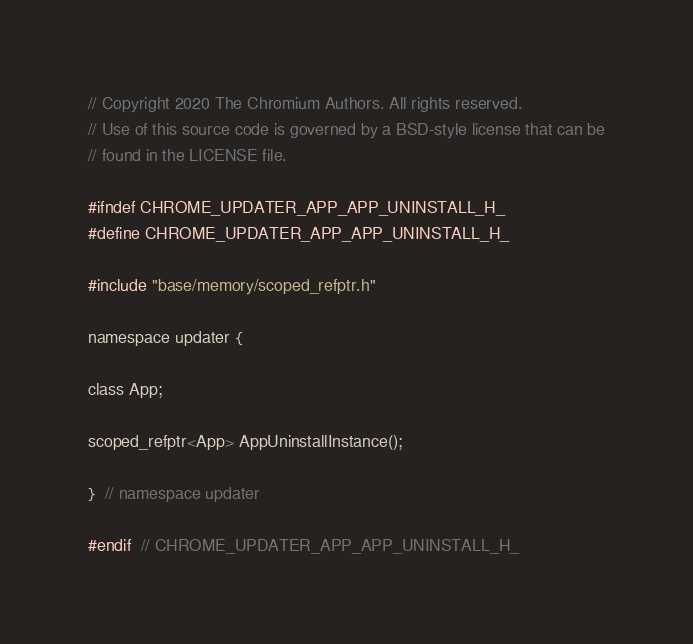Convert code to text. <code><loc_0><loc_0><loc_500><loc_500><_C_>// Copyright 2020 The Chromium Authors. All rights reserved.
// Use of this source code is governed by a BSD-style license that can be
// found in the LICENSE file.

#ifndef CHROME_UPDATER_APP_APP_UNINSTALL_H_
#define CHROME_UPDATER_APP_APP_UNINSTALL_H_

#include "base/memory/scoped_refptr.h"

namespace updater {

class App;

scoped_refptr<App> AppUninstallInstance();

}  // namespace updater

#endif  // CHROME_UPDATER_APP_APP_UNINSTALL_H_
</code> 